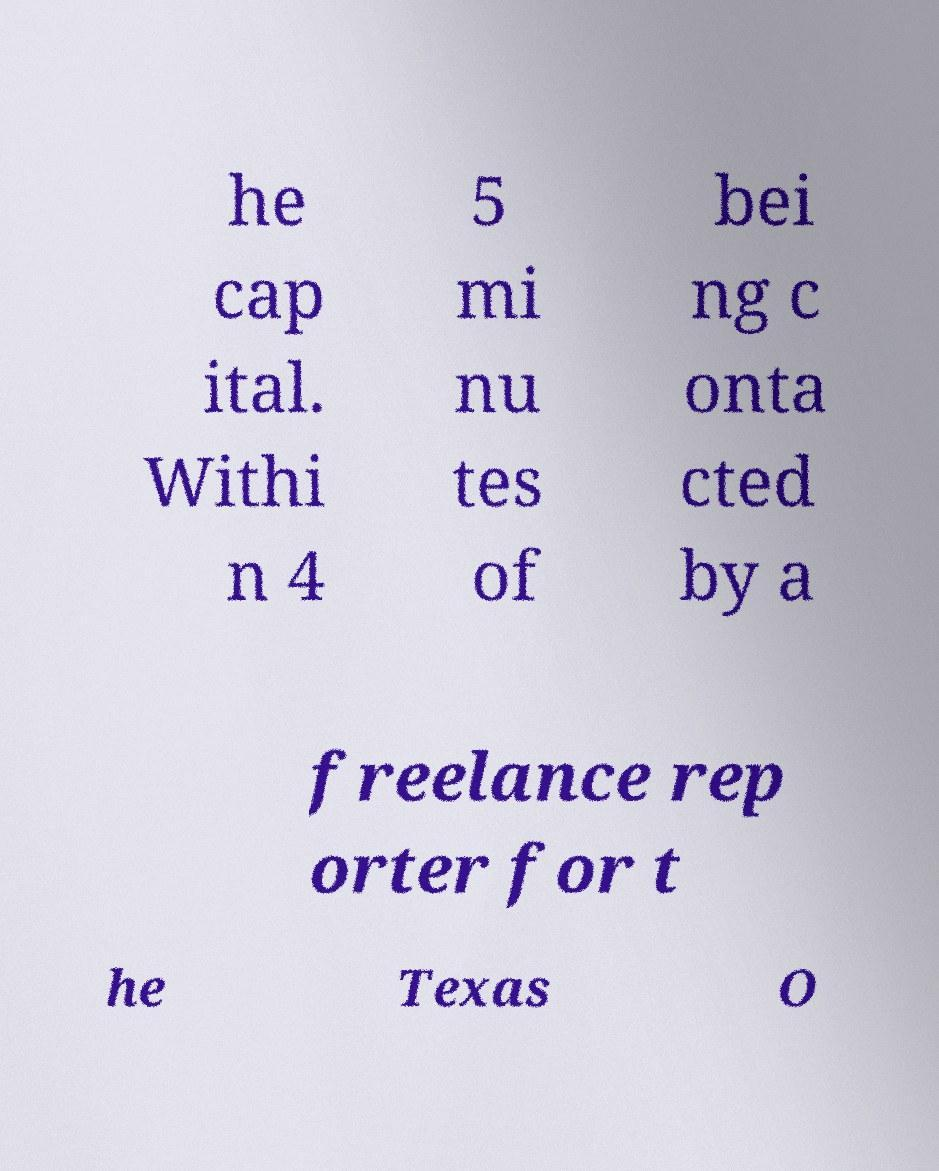For documentation purposes, I need the text within this image transcribed. Could you provide that? he cap ital. Withi n 4 5 mi nu tes of bei ng c onta cted by a freelance rep orter for t he Texas O 